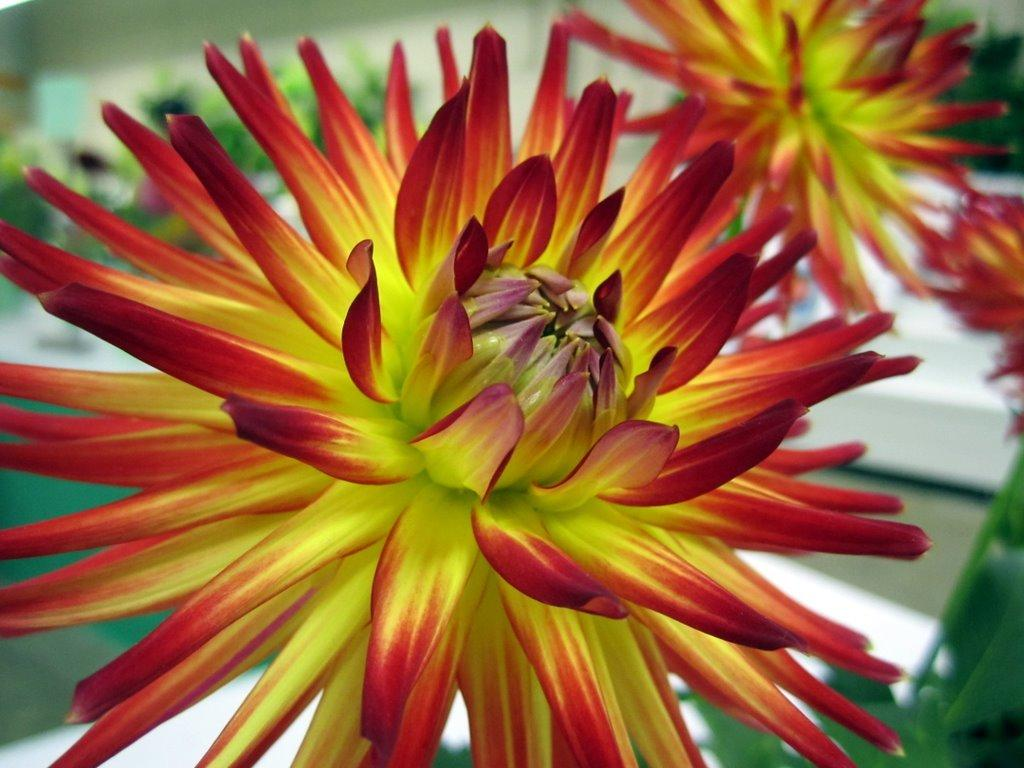What colors of flowers can be seen in the image? There are yellow and red flowers in the image. Can you describe the background of the image? The background of the image is blurred. How many nerves are visible in the image? There are no nerves visible in the image; it features flowers. What type of shoes is the queen wearing in the image? There is no queen or shoes present in the image; it features flowers and a blurred background. 